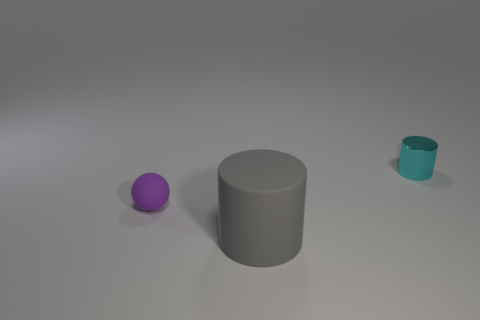Are there an equal number of gray rubber things right of the shiny thing and big gray matte blocks?
Provide a short and direct response. Yes. Are there any large gray matte things on the right side of the matte ball?
Ensure brevity in your answer.  Yes. There is a big rubber object; is its shape the same as the thing that is to the right of the large gray matte object?
Provide a succinct answer. Yes. What color is the tiny object that is the same material as the large gray cylinder?
Offer a very short reply. Purple. What is the color of the tiny ball?
Your answer should be compact. Purple. Are the large gray cylinder and the small thing that is on the left side of the gray matte object made of the same material?
Your answer should be very brief. Yes. What number of objects are both in front of the cyan metallic cylinder and on the right side of the tiny purple object?
Your response must be concise. 1. What shape is the purple object that is the same size as the metal cylinder?
Your response must be concise. Sphere. Are there any tiny cyan metallic things that are to the right of the cylinder in front of the tiny thing that is in front of the cyan shiny thing?
Ensure brevity in your answer.  Yes. There is a rubber thing to the right of the tiny object that is in front of the cyan metallic cylinder; how big is it?
Your answer should be very brief. Large. 